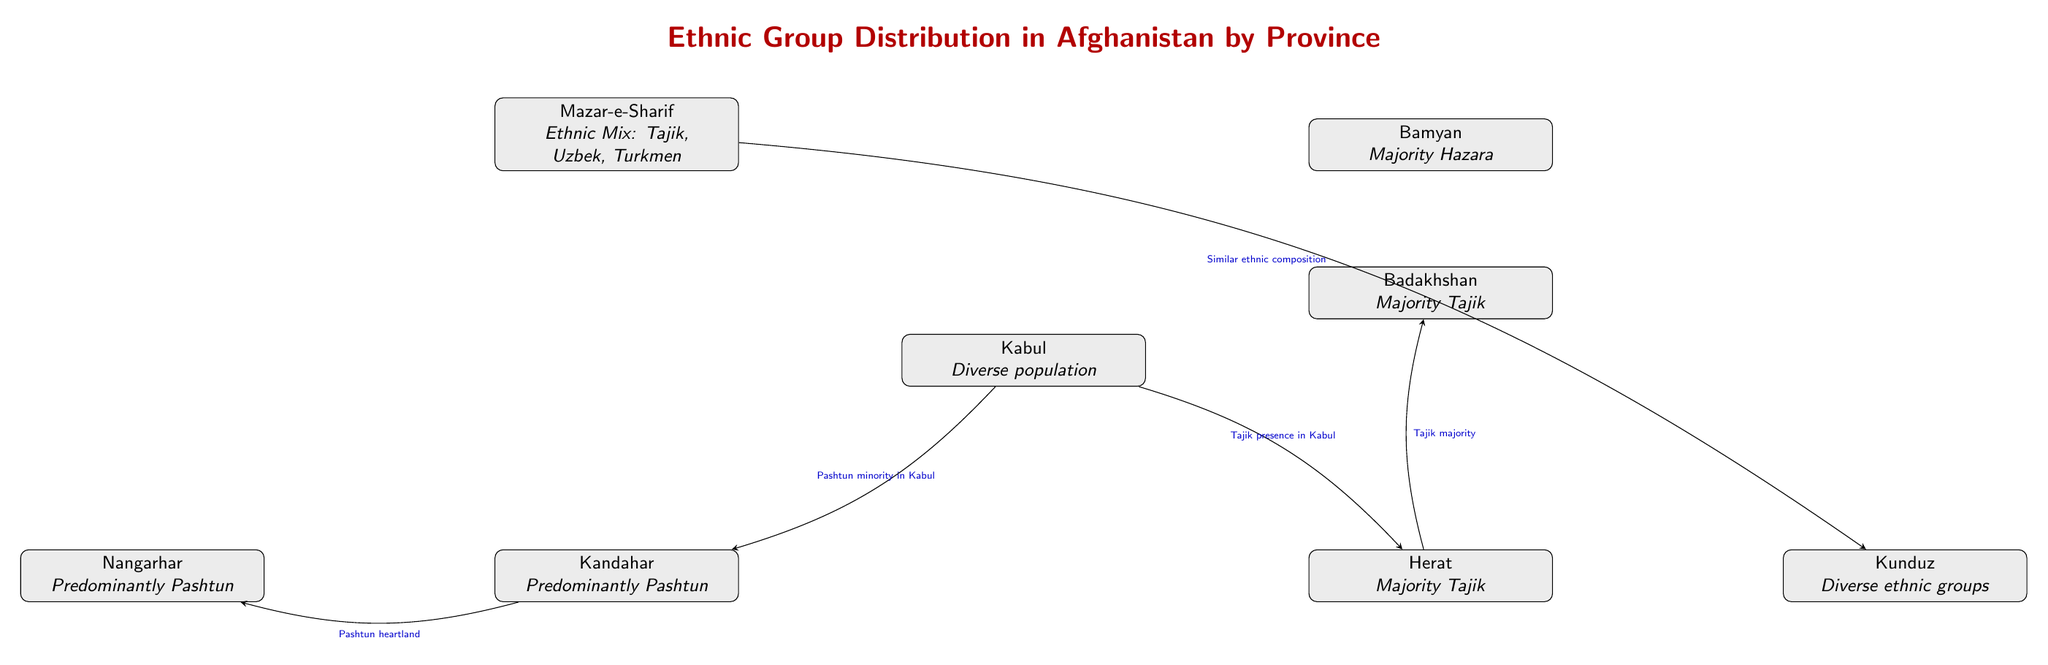What majority ethnic group is found in Bamyan? The diagram states that Bamyan has a "Majority Hazara," indicating that the Hazara ethnic group constitutes the largest demographic in this province.
Answer: Hazara Which province is described as having a diverse population? In the diagram, Kabul is mentioned as having a "Diverse population," signifying that its ethnic composition is varied.
Answer: Kabul What connection exists between Kabul and Kandahar? The diagram specifies that there is a connection indicating a "Pashtun minority in Kabul," showing the relationship between the populations of these two provinces.
Answer: Pashtun minority in Kabul How many provinces are connected to Herat? Counting the connections displayed in the diagram, Herat is connected to two provinces: Kabul and Badakhshan.
Answer: 2 Which provinces are predominantly Pashtun? The diagram highlights Kandahar and Nangarhar as having a "Predominantly Pashtun" identification, meaning these two provinces have a majority Pashtun population.
Answer: Kandahar, Nangarhar What type of ethnic mix is found in Mazar-e-Sharif? The diagram notes that Mazar-e-Sharif has an "Ethnic Mix: Tajik, Uzbek, Turkmen," indicating a variety of ethnic backgrounds present in this province.
Answer: Tajik, Uzbek, Turkmen Which province is directly above Kabul in the diagram? The diagram visually places Bamyan directly above Kabul, indicating its geographic relation in the representation.
Answer: Bamyan What relationship is shown between Mazar-e-Sharif and Kunduz? The diagram describes a connection noting "Similar ethnic composition," which suggests that both regions have comparable ethnic demographics.
Answer: Similar ethnic composition Which province is marked as Pashtun heartland? The diagram identifies Kandahar, with the connection marked as "Pashtun heartland," indicating its significance to Pashtun ethnicity.
Answer: Kandahar 